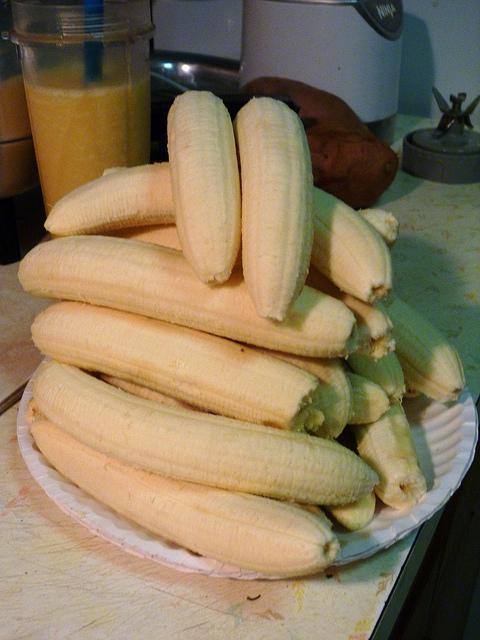What happened to these bananas?
Select the accurate answer and provide explanation: 'Answer: answer
Rationale: rationale.'
Options: Fried, peeled, baked, chopped. Answer: peeled.
Rationale: The bananas no longer have skins on them. 